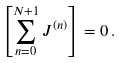<formula> <loc_0><loc_0><loc_500><loc_500>\left [ \sum _ { n = 0 } ^ { N + 1 } J ^ { ( n ) } \right ] = 0 \, .</formula> 